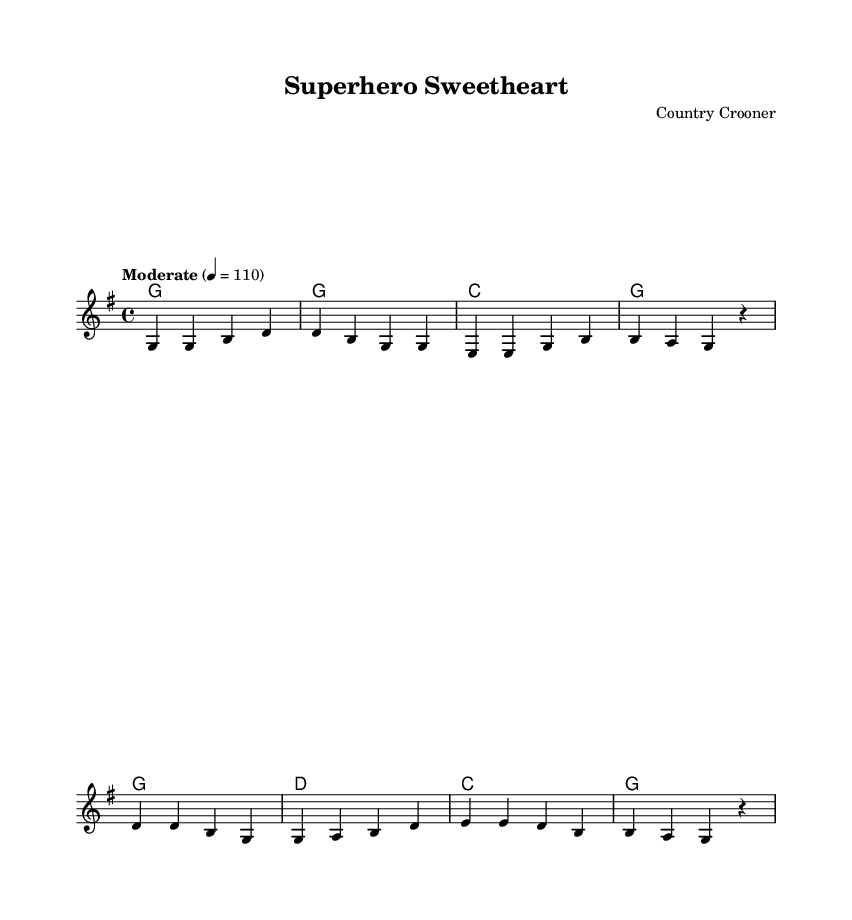What is the key signature of this music? The key signature is indicated by the sharps or flats at the beginning of the staff. In this case, there are no sharps or flats, which corresponds to G major.
Answer: G major What is the time signature of this music? The time signature is shown at the beginning of the staff, represented by two numbers stacked one above the other. Here, it is 4 over 4, indicating four beats per measure.
Answer: 4/4 What is the tempo marking in this score? The tempo is usually indicated above the staff, and in this case, it states "Moderate" at a speed of 110 beats per minute.
Answer: Moderate 110 What is the first word of the chorus? The first word of the chorus is found by looking at the lyrics corresponding to the melody section marked as the chorus. The lyrics start with "My."
Answer: My How many measures are in the verse? To find the number of measures, you count the vertical lines that divide the staff into segments, which denotes each measure. The verse consists of four measures.
Answer: Four Describe the overall theme of the song. The theme can be inferred from the lyrics provided, which describe a relationship with someone who is deeply into superhero movies and culture. The playful tone reflects the singer's lighthearted approach to her obsession.
Answer: Superhero obsession What genre does this song belong to? The genre is indicated by the style of music and its typical elements such as harmony, lyrics, and instrumentation. This music has characteristics of country, evident from its structure and lyrics.
Answer: Country 